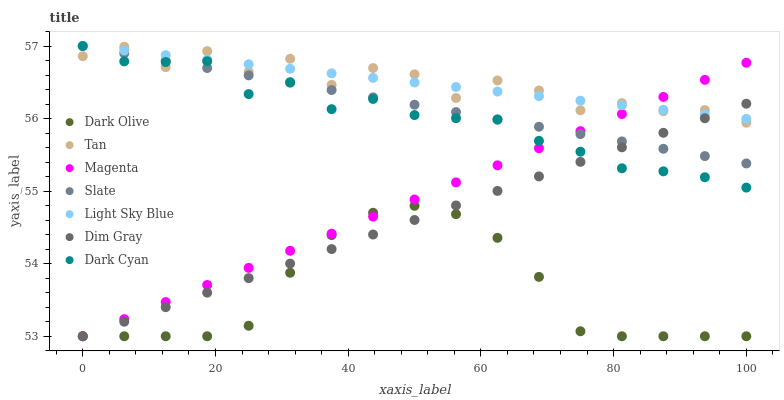Does Dark Olive have the minimum area under the curve?
Answer yes or no. Yes. Does Tan have the maximum area under the curve?
Answer yes or no. Yes. Does Slate have the minimum area under the curve?
Answer yes or no. No. Does Slate have the maximum area under the curve?
Answer yes or no. No. Is Light Sky Blue the smoothest?
Answer yes or no. Yes. Is Tan the roughest?
Answer yes or no. Yes. Is Slate the smoothest?
Answer yes or no. No. Is Slate the roughest?
Answer yes or no. No. Does Dim Gray have the lowest value?
Answer yes or no. Yes. Does Slate have the lowest value?
Answer yes or no. No. Does Dark Cyan have the highest value?
Answer yes or no. Yes. Does Dark Olive have the highest value?
Answer yes or no. No. Is Dark Olive less than Tan?
Answer yes or no. Yes. Is Dark Cyan greater than Dark Olive?
Answer yes or no. Yes. Does Dim Gray intersect Dark Olive?
Answer yes or no. Yes. Is Dim Gray less than Dark Olive?
Answer yes or no. No. Is Dim Gray greater than Dark Olive?
Answer yes or no. No. Does Dark Olive intersect Tan?
Answer yes or no. No. 